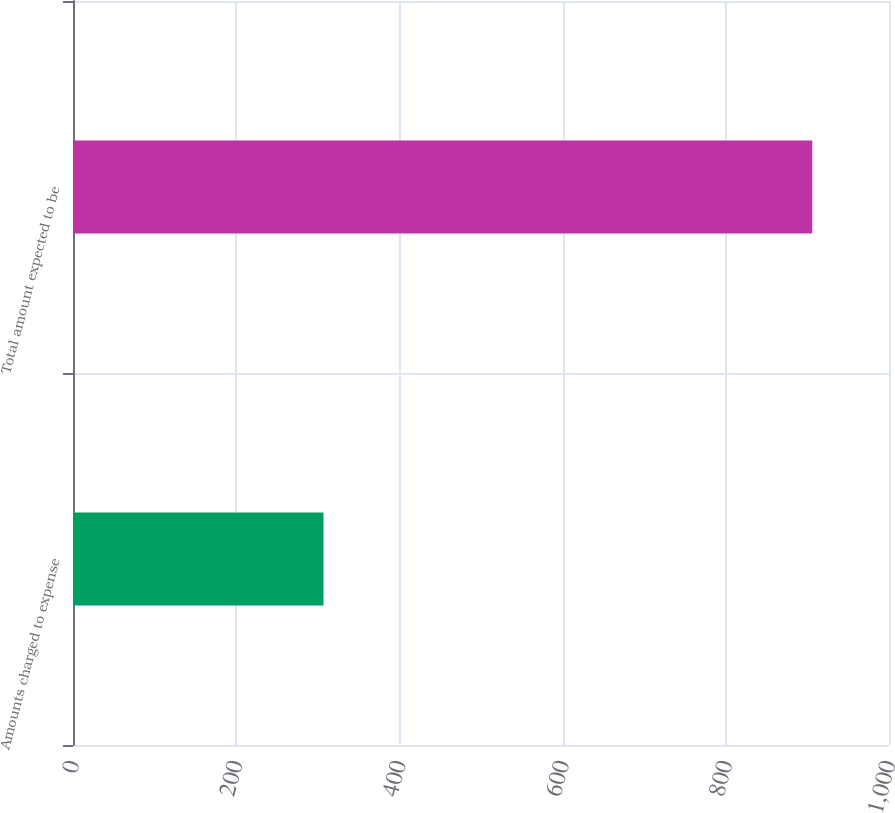<chart> <loc_0><loc_0><loc_500><loc_500><bar_chart><fcel>Amounts charged to expense<fcel>Total amount expected to be<nl><fcel>307<fcel>906<nl></chart> 